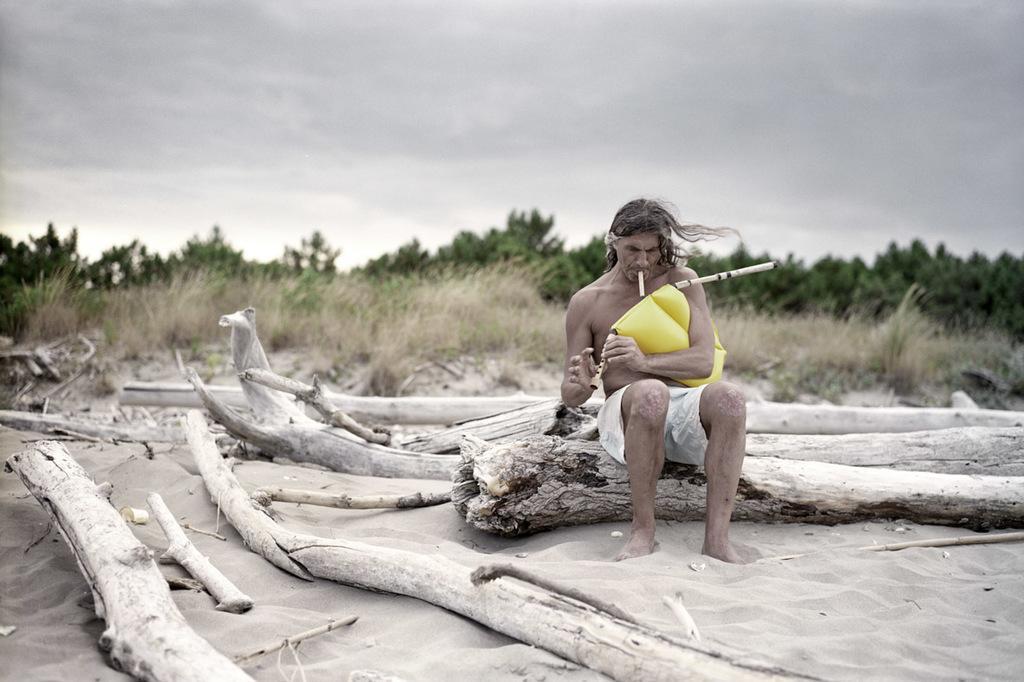Please provide a concise description of this image. In the center of the image there is a person sitting on the wooden log and he is holding some object. Beside him there are wooden logs. Behind him there is grass on the surface. In the background of the image there are trees and sky. At the bottom of the image there is sand. 